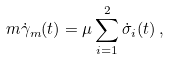<formula> <loc_0><loc_0><loc_500><loc_500>m \dot { \gamma } _ { m } ( t ) = \mu \sum ^ { 2 } _ { i = 1 } \dot { \sigma } _ { i } ( t ) \, ,</formula> 